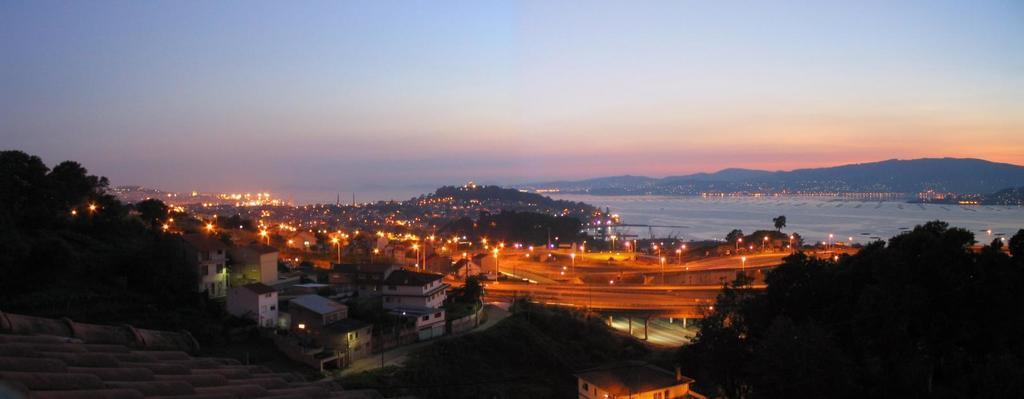Can you describe this image briefly? In the image there are many buildings with lights. And also there are trees. There are flyovers with pillars. And also there are poles with street lights. Behind them there is water. In the background there are hills. At the top of the image there is sky.  